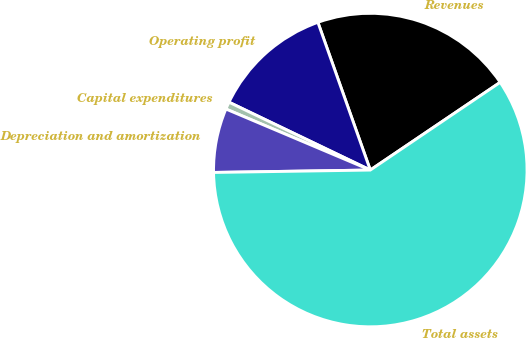Convert chart. <chart><loc_0><loc_0><loc_500><loc_500><pie_chart><fcel>Revenues<fcel>Operating profit<fcel>Capital expenditures<fcel>Depreciation and amortization<fcel>Total assets<nl><fcel>20.97%<fcel>12.45%<fcel>0.76%<fcel>6.61%<fcel>59.21%<nl></chart> 